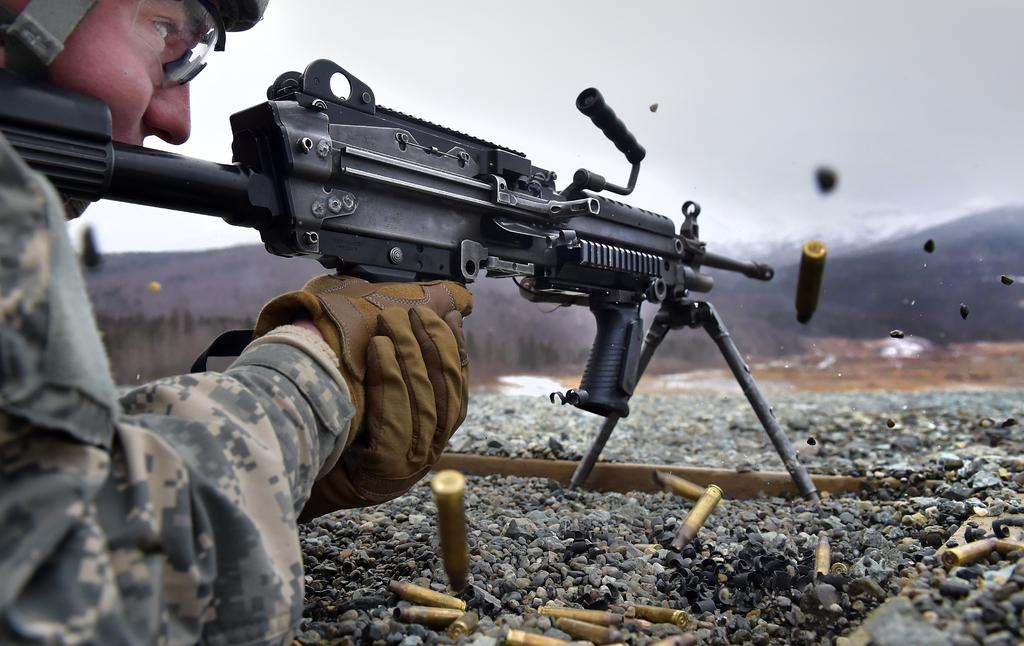Who or what is present in the image? There is a person in the image. What is the person holding in the image? The person is holding a gun in the image. Are there any additional items related to the gun visible in the image? Yes, there are bullets in the image. What type of natural landscape can be seen in the image? There are mountains visible in the image. How many cats are visible in the image? There are no cats present in the image. Are there any fairies flying around the mountains in the image? There are no fairies visible in the image. 